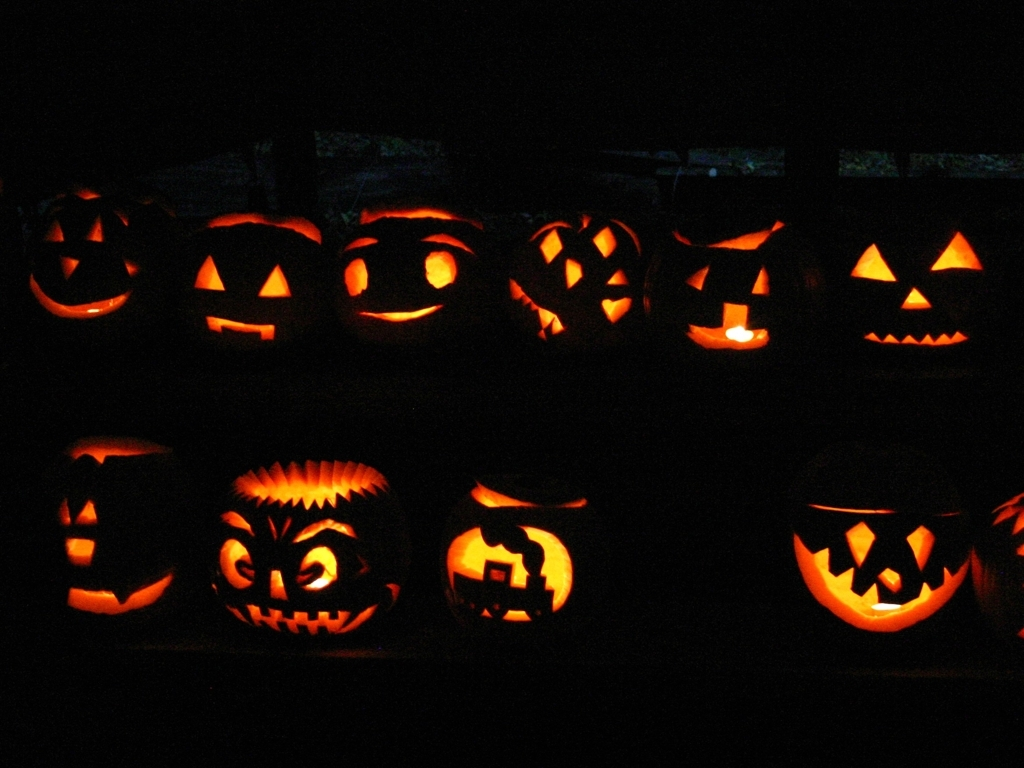How can I preserve a carved pumpkin to last longer? To preserve your carved pumpkin, you can start by scooping out all the pulp and seeds thoroughly. Then, apply petroleum jelly to the cut edges to seal in moisture. Spraying the pumpkin with a mixture of bleach and water can ward off mold. Keeping it in a cool place away from direct sunlight will also help extend its life. 